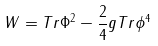Convert formula to latex. <formula><loc_0><loc_0><loc_500><loc_500>W = T r \Phi ^ { 2 } - \frac { 2 } { 4 } g T r \phi ^ { 4 }</formula> 